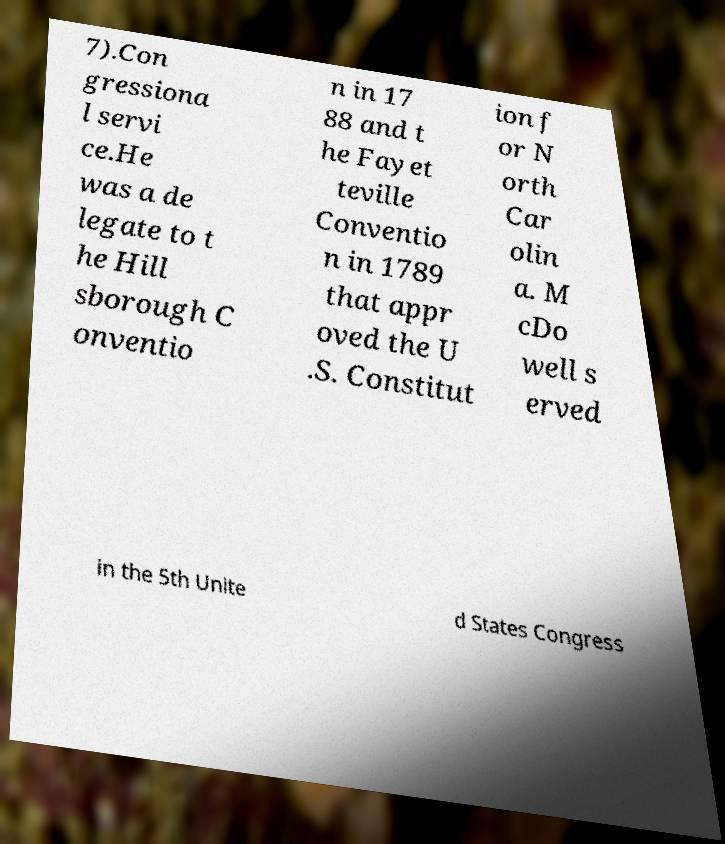Could you assist in decoding the text presented in this image and type it out clearly? 7).Con gressiona l servi ce.He was a de legate to t he Hill sborough C onventio n in 17 88 and t he Fayet teville Conventio n in 1789 that appr oved the U .S. Constitut ion f or N orth Car olin a. M cDo well s erved in the 5th Unite d States Congress 